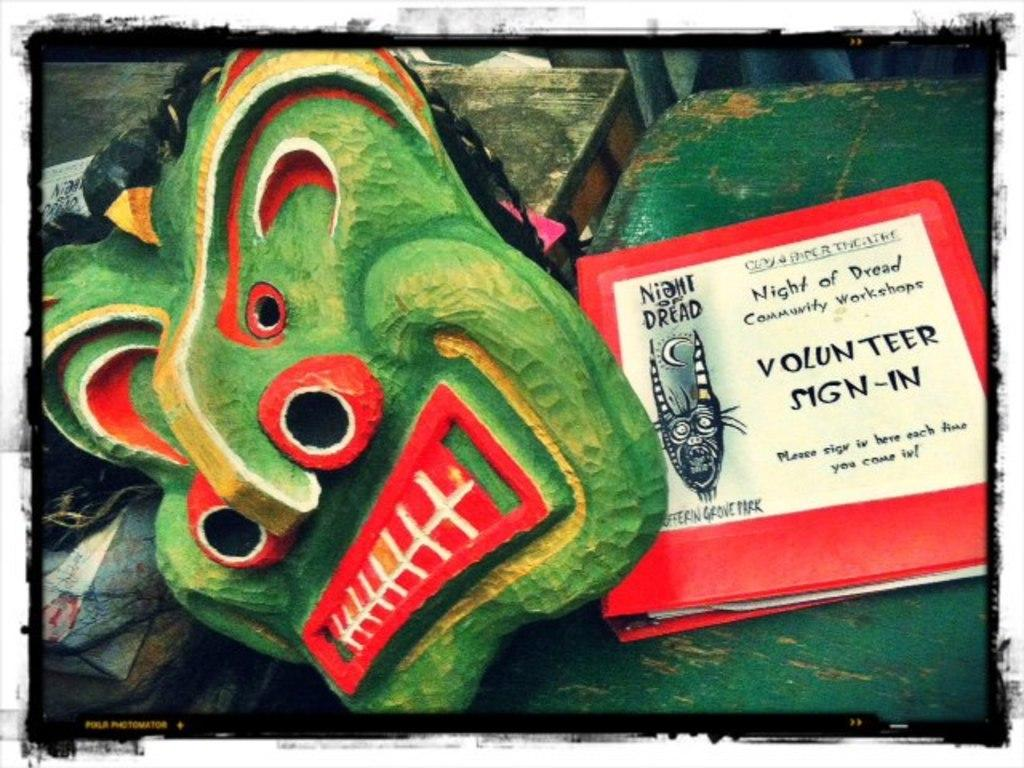What type of furniture is present in the image? There are tables in the image. What is placed on the tables? There is at least one mask and one file on the tables. Can you describe the text be seen on any of the items on the tables? Yes, there is text on the file. What else can be seen on the tables? There are unspecified objects on the tables. What type of crown is visible on the table in the image? There is no crown present in the image. How many fingers can be seen on the table in the image? There are no fingers visible in the image. 